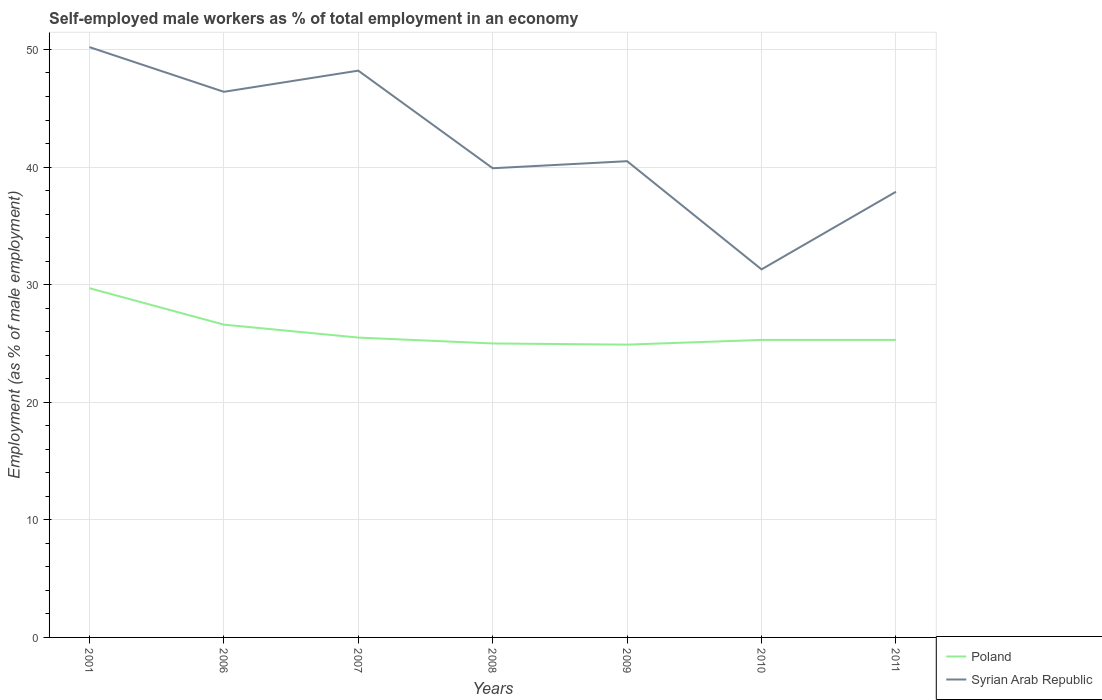How many different coloured lines are there?
Keep it short and to the point. 2. Is the number of lines equal to the number of legend labels?
Your answer should be compact. Yes. Across all years, what is the maximum percentage of self-employed male workers in Syrian Arab Republic?
Offer a terse response. 31.3. What is the total percentage of self-employed male workers in Poland in the graph?
Provide a succinct answer. 1.3. What is the difference between the highest and the second highest percentage of self-employed male workers in Syrian Arab Republic?
Offer a terse response. 18.9. Is the percentage of self-employed male workers in Poland strictly greater than the percentage of self-employed male workers in Syrian Arab Republic over the years?
Give a very brief answer. Yes. How many lines are there?
Offer a terse response. 2. How many years are there in the graph?
Keep it short and to the point. 7. What is the difference between two consecutive major ticks on the Y-axis?
Your response must be concise. 10. Does the graph contain any zero values?
Provide a short and direct response. No. Where does the legend appear in the graph?
Ensure brevity in your answer.  Bottom right. What is the title of the graph?
Your answer should be very brief. Self-employed male workers as % of total employment in an economy. Does "Kosovo" appear as one of the legend labels in the graph?
Your answer should be compact. No. What is the label or title of the Y-axis?
Provide a succinct answer. Employment (as % of male employment). What is the Employment (as % of male employment) of Poland in 2001?
Provide a short and direct response. 29.7. What is the Employment (as % of male employment) in Syrian Arab Republic in 2001?
Provide a short and direct response. 50.2. What is the Employment (as % of male employment) of Poland in 2006?
Ensure brevity in your answer.  26.6. What is the Employment (as % of male employment) of Syrian Arab Republic in 2006?
Provide a short and direct response. 46.4. What is the Employment (as % of male employment) of Poland in 2007?
Your response must be concise. 25.5. What is the Employment (as % of male employment) in Syrian Arab Republic in 2007?
Offer a very short reply. 48.2. What is the Employment (as % of male employment) in Poland in 2008?
Your response must be concise. 25. What is the Employment (as % of male employment) of Syrian Arab Republic in 2008?
Keep it short and to the point. 39.9. What is the Employment (as % of male employment) of Poland in 2009?
Give a very brief answer. 24.9. What is the Employment (as % of male employment) of Syrian Arab Republic in 2009?
Your response must be concise. 40.5. What is the Employment (as % of male employment) of Poland in 2010?
Provide a succinct answer. 25.3. What is the Employment (as % of male employment) in Syrian Arab Republic in 2010?
Keep it short and to the point. 31.3. What is the Employment (as % of male employment) in Poland in 2011?
Your answer should be very brief. 25.3. What is the Employment (as % of male employment) in Syrian Arab Republic in 2011?
Offer a very short reply. 37.9. Across all years, what is the maximum Employment (as % of male employment) of Poland?
Your answer should be compact. 29.7. Across all years, what is the maximum Employment (as % of male employment) of Syrian Arab Republic?
Give a very brief answer. 50.2. Across all years, what is the minimum Employment (as % of male employment) of Poland?
Your answer should be compact. 24.9. Across all years, what is the minimum Employment (as % of male employment) of Syrian Arab Republic?
Provide a succinct answer. 31.3. What is the total Employment (as % of male employment) of Poland in the graph?
Ensure brevity in your answer.  182.3. What is the total Employment (as % of male employment) of Syrian Arab Republic in the graph?
Your answer should be compact. 294.4. What is the difference between the Employment (as % of male employment) of Syrian Arab Republic in 2001 and that in 2006?
Your response must be concise. 3.8. What is the difference between the Employment (as % of male employment) in Syrian Arab Republic in 2001 and that in 2007?
Your answer should be compact. 2. What is the difference between the Employment (as % of male employment) in Poland in 2001 and that in 2008?
Offer a terse response. 4.7. What is the difference between the Employment (as % of male employment) of Syrian Arab Republic in 2001 and that in 2008?
Your response must be concise. 10.3. What is the difference between the Employment (as % of male employment) in Poland in 2001 and that in 2009?
Ensure brevity in your answer.  4.8. What is the difference between the Employment (as % of male employment) in Poland in 2001 and that in 2010?
Provide a succinct answer. 4.4. What is the difference between the Employment (as % of male employment) in Syrian Arab Republic in 2001 and that in 2010?
Your answer should be very brief. 18.9. What is the difference between the Employment (as % of male employment) in Poland in 2001 and that in 2011?
Make the answer very short. 4.4. What is the difference between the Employment (as % of male employment) of Syrian Arab Republic in 2006 and that in 2007?
Provide a succinct answer. -1.8. What is the difference between the Employment (as % of male employment) in Poland in 2006 and that in 2008?
Ensure brevity in your answer.  1.6. What is the difference between the Employment (as % of male employment) of Syrian Arab Republic in 2006 and that in 2008?
Ensure brevity in your answer.  6.5. What is the difference between the Employment (as % of male employment) in Poland in 2006 and that in 2009?
Offer a very short reply. 1.7. What is the difference between the Employment (as % of male employment) in Poland in 2006 and that in 2010?
Give a very brief answer. 1.3. What is the difference between the Employment (as % of male employment) of Poland in 2007 and that in 2008?
Offer a terse response. 0.5. What is the difference between the Employment (as % of male employment) of Syrian Arab Republic in 2007 and that in 2008?
Your answer should be very brief. 8.3. What is the difference between the Employment (as % of male employment) in Poland in 2007 and that in 2009?
Your response must be concise. 0.6. What is the difference between the Employment (as % of male employment) in Poland in 2007 and that in 2010?
Provide a short and direct response. 0.2. What is the difference between the Employment (as % of male employment) of Poland in 2007 and that in 2011?
Keep it short and to the point. 0.2. What is the difference between the Employment (as % of male employment) in Syrian Arab Republic in 2007 and that in 2011?
Provide a succinct answer. 10.3. What is the difference between the Employment (as % of male employment) of Poland in 2008 and that in 2009?
Provide a short and direct response. 0.1. What is the difference between the Employment (as % of male employment) in Syrian Arab Republic in 2008 and that in 2009?
Your answer should be very brief. -0.6. What is the difference between the Employment (as % of male employment) in Poland in 2008 and that in 2010?
Provide a short and direct response. -0.3. What is the difference between the Employment (as % of male employment) of Poland in 2009 and that in 2010?
Make the answer very short. -0.4. What is the difference between the Employment (as % of male employment) of Poland in 2009 and that in 2011?
Keep it short and to the point. -0.4. What is the difference between the Employment (as % of male employment) of Poland in 2001 and the Employment (as % of male employment) of Syrian Arab Republic in 2006?
Offer a terse response. -16.7. What is the difference between the Employment (as % of male employment) of Poland in 2001 and the Employment (as % of male employment) of Syrian Arab Republic in 2007?
Provide a succinct answer. -18.5. What is the difference between the Employment (as % of male employment) of Poland in 2001 and the Employment (as % of male employment) of Syrian Arab Republic in 2008?
Ensure brevity in your answer.  -10.2. What is the difference between the Employment (as % of male employment) in Poland in 2001 and the Employment (as % of male employment) in Syrian Arab Republic in 2011?
Offer a very short reply. -8.2. What is the difference between the Employment (as % of male employment) of Poland in 2006 and the Employment (as % of male employment) of Syrian Arab Republic in 2007?
Offer a very short reply. -21.6. What is the difference between the Employment (as % of male employment) of Poland in 2006 and the Employment (as % of male employment) of Syrian Arab Republic in 2009?
Make the answer very short. -13.9. What is the difference between the Employment (as % of male employment) of Poland in 2006 and the Employment (as % of male employment) of Syrian Arab Republic in 2010?
Make the answer very short. -4.7. What is the difference between the Employment (as % of male employment) in Poland in 2006 and the Employment (as % of male employment) in Syrian Arab Republic in 2011?
Provide a succinct answer. -11.3. What is the difference between the Employment (as % of male employment) in Poland in 2007 and the Employment (as % of male employment) in Syrian Arab Republic in 2008?
Your answer should be very brief. -14.4. What is the difference between the Employment (as % of male employment) in Poland in 2008 and the Employment (as % of male employment) in Syrian Arab Republic in 2009?
Keep it short and to the point. -15.5. What is the difference between the Employment (as % of male employment) in Poland in 2008 and the Employment (as % of male employment) in Syrian Arab Republic in 2011?
Offer a very short reply. -12.9. What is the difference between the Employment (as % of male employment) of Poland in 2009 and the Employment (as % of male employment) of Syrian Arab Republic in 2010?
Ensure brevity in your answer.  -6.4. What is the difference between the Employment (as % of male employment) of Poland in 2009 and the Employment (as % of male employment) of Syrian Arab Republic in 2011?
Keep it short and to the point. -13. What is the difference between the Employment (as % of male employment) in Poland in 2010 and the Employment (as % of male employment) in Syrian Arab Republic in 2011?
Provide a succinct answer. -12.6. What is the average Employment (as % of male employment) of Poland per year?
Your response must be concise. 26.04. What is the average Employment (as % of male employment) in Syrian Arab Republic per year?
Offer a terse response. 42.06. In the year 2001, what is the difference between the Employment (as % of male employment) of Poland and Employment (as % of male employment) of Syrian Arab Republic?
Your answer should be compact. -20.5. In the year 2006, what is the difference between the Employment (as % of male employment) of Poland and Employment (as % of male employment) of Syrian Arab Republic?
Provide a succinct answer. -19.8. In the year 2007, what is the difference between the Employment (as % of male employment) of Poland and Employment (as % of male employment) of Syrian Arab Republic?
Keep it short and to the point. -22.7. In the year 2008, what is the difference between the Employment (as % of male employment) of Poland and Employment (as % of male employment) of Syrian Arab Republic?
Offer a very short reply. -14.9. In the year 2009, what is the difference between the Employment (as % of male employment) of Poland and Employment (as % of male employment) of Syrian Arab Republic?
Your answer should be very brief. -15.6. What is the ratio of the Employment (as % of male employment) of Poland in 2001 to that in 2006?
Your answer should be compact. 1.12. What is the ratio of the Employment (as % of male employment) in Syrian Arab Republic in 2001 to that in 2006?
Ensure brevity in your answer.  1.08. What is the ratio of the Employment (as % of male employment) of Poland in 2001 to that in 2007?
Offer a very short reply. 1.16. What is the ratio of the Employment (as % of male employment) in Syrian Arab Republic in 2001 to that in 2007?
Your answer should be very brief. 1.04. What is the ratio of the Employment (as % of male employment) of Poland in 2001 to that in 2008?
Your answer should be compact. 1.19. What is the ratio of the Employment (as % of male employment) in Syrian Arab Republic in 2001 to that in 2008?
Offer a very short reply. 1.26. What is the ratio of the Employment (as % of male employment) in Poland in 2001 to that in 2009?
Make the answer very short. 1.19. What is the ratio of the Employment (as % of male employment) in Syrian Arab Republic in 2001 to that in 2009?
Give a very brief answer. 1.24. What is the ratio of the Employment (as % of male employment) in Poland in 2001 to that in 2010?
Provide a succinct answer. 1.17. What is the ratio of the Employment (as % of male employment) in Syrian Arab Republic in 2001 to that in 2010?
Keep it short and to the point. 1.6. What is the ratio of the Employment (as % of male employment) in Poland in 2001 to that in 2011?
Make the answer very short. 1.17. What is the ratio of the Employment (as % of male employment) of Syrian Arab Republic in 2001 to that in 2011?
Your answer should be very brief. 1.32. What is the ratio of the Employment (as % of male employment) in Poland in 2006 to that in 2007?
Your answer should be compact. 1.04. What is the ratio of the Employment (as % of male employment) in Syrian Arab Republic in 2006 to that in 2007?
Your response must be concise. 0.96. What is the ratio of the Employment (as % of male employment) in Poland in 2006 to that in 2008?
Ensure brevity in your answer.  1.06. What is the ratio of the Employment (as % of male employment) of Syrian Arab Republic in 2006 to that in 2008?
Your response must be concise. 1.16. What is the ratio of the Employment (as % of male employment) of Poland in 2006 to that in 2009?
Offer a terse response. 1.07. What is the ratio of the Employment (as % of male employment) in Syrian Arab Republic in 2006 to that in 2009?
Your answer should be compact. 1.15. What is the ratio of the Employment (as % of male employment) of Poland in 2006 to that in 2010?
Give a very brief answer. 1.05. What is the ratio of the Employment (as % of male employment) in Syrian Arab Republic in 2006 to that in 2010?
Provide a succinct answer. 1.48. What is the ratio of the Employment (as % of male employment) of Poland in 2006 to that in 2011?
Keep it short and to the point. 1.05. What is the ratio of the Employment (as % of male employment) of Syrian Arab Republic in 2006 to that in 2011?
Your answer should be very brief. 1.22. What is the ratio of the Employment (as % of male employment) of Poland in 2007 to that in 2008?
Provide a short and direct response. 1.02. What is the ratio of the Employment (as % of male employment) in Syrian Arab Republic in 2007 to that in 2008?
Your response must be concise. 1.21. What is the ratio of the Employment (as % of male employment) in Poland in 2007 to that in 2009?
Your answer should be compact. 1.02. What is the ratio of the Employment (as % of male employment) of Syrian Arab Republic in 2007 to that in 2009?
Offer a very short reply. 1.19. What is the ratio of the Employment (as % of male employment) in Poland in 2007 to that in 2010?
Make the answer very short. 1.01. What is the ratio of the Employment (as % of male employment) in Syrian Arab Republic in 2007 to that in 2010?
Your answer should be very brief. 1.54. What is the ratio of the Employment (as % of male employment) in Poland in 2007 to that in 2011?
Provide a succinct answer. 1.01. What is the ratio of the Employment (as % of male employment) in Syrian Arab Republic in 2007 to that in 2011?
Your answer should be very brief. 1.27. What is the ratio of the Employment (as % of male employment) in Poland in 2008 to that in 2009?
Make the answer very short. 1. What is the ratio of the Employment (as % of male employment) in Syrian Arab Republic in 2008 to that in 2009?
Make the answer very short. 0.99. What is the ratio of the Employment (as % of male employment) in Syrian Arab Republic in 2008 to that in 2010?
Offer a terse response. 1.27. What is the ratio of the Employment (as % of male employment) of Poland in 2008 to that in 2011?
Give a very brief answer. 0.99. What is the ratio of the Employment (as % of male employment) of Syrian Arab Republic in 2008 to that in 2011?
Make the answer very short. 1.05. What is the ratio of the Employment (as % of male employment) of Poland in 2009 to that in 2010?
Keep it short and to the point. 0.98. What is the ratio of the Employment (as % of male employment) of Syrian Arab Republic in 2009 to that in 2010?
Offer a very short reply. 1.29. What is the ratio of the Employment (as % of male employment) of Poland in 2009 to that in 2011?
Provide a succinct answer. 0.98. What is the ratio of the Employment (as % of male employment) in Syrian Arab Republic in 2009 to that in 2011?
Offer a very short reply. 1.07. What is the ratio of the Employment (as % of male employment) in Syrian Arab Republic in 2010 to that in 2011?
Your answer should be very brief. 0.83. What is the difference between the highest and the second highest Employment (as % of male employment) of Poland?
Make the answer very short. 3.1. 